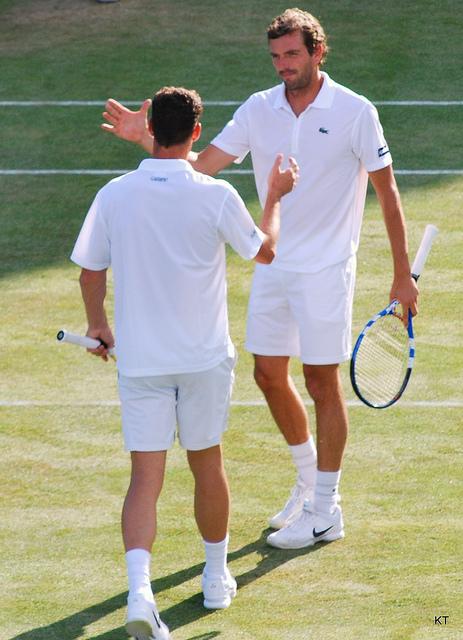Are they good sports?
Write a very short answer. Yes. Is the match over?
Give a very brief answer. Yes. What sport do these men participate in?
Write a very short answer. Tennis. 